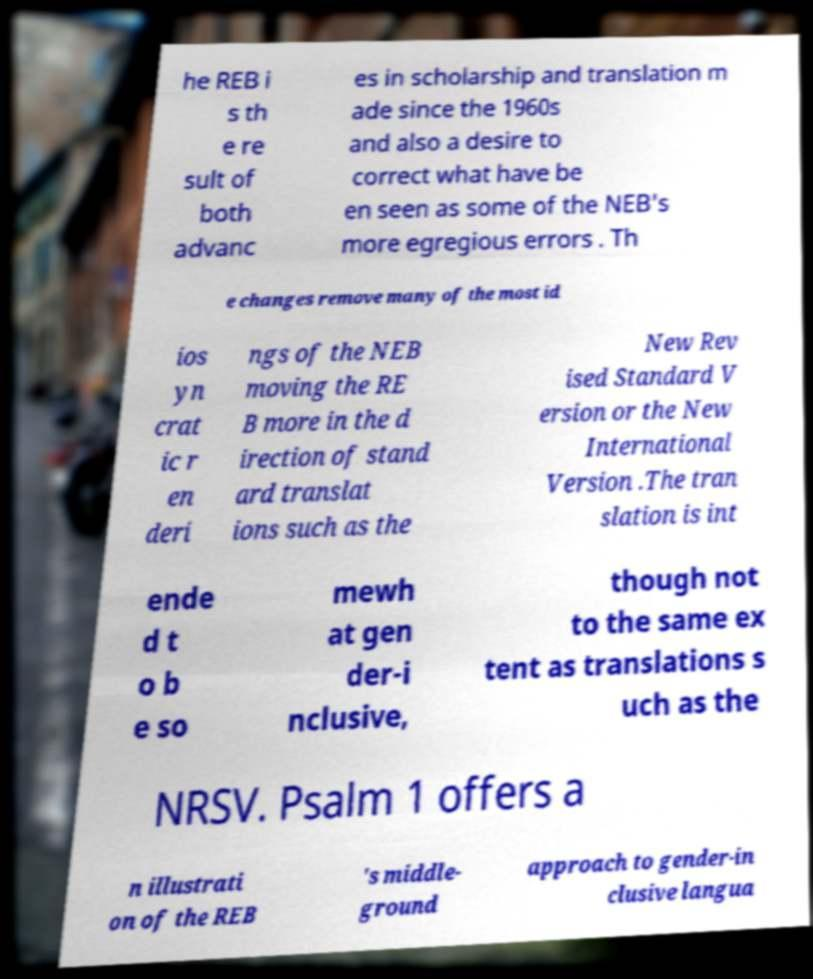What messages or text are displayed in this image? I need them in a readable, typed format. he REB i s th e re sult of both advanc es in scholarship and translation m ade since the 1960s and also a desire to correct what have be en seen as some of the NEB's more egregious errors . Th e changes remove many of the most id ios yn crat ic r en deri ngs of the NEB moving the RE B more in the d irection of stand ard translat ions such as the New Rev ised Standard V ersion or the New International Version .The tran slation is int ende d t o b e so mewh at gen der-i nclusive, though not to the same ex tent as translations s uch as the NRSV. Psalm 1 offers a n illustrati on of the REB 's middle- ground approach to gender-in clusive langua 